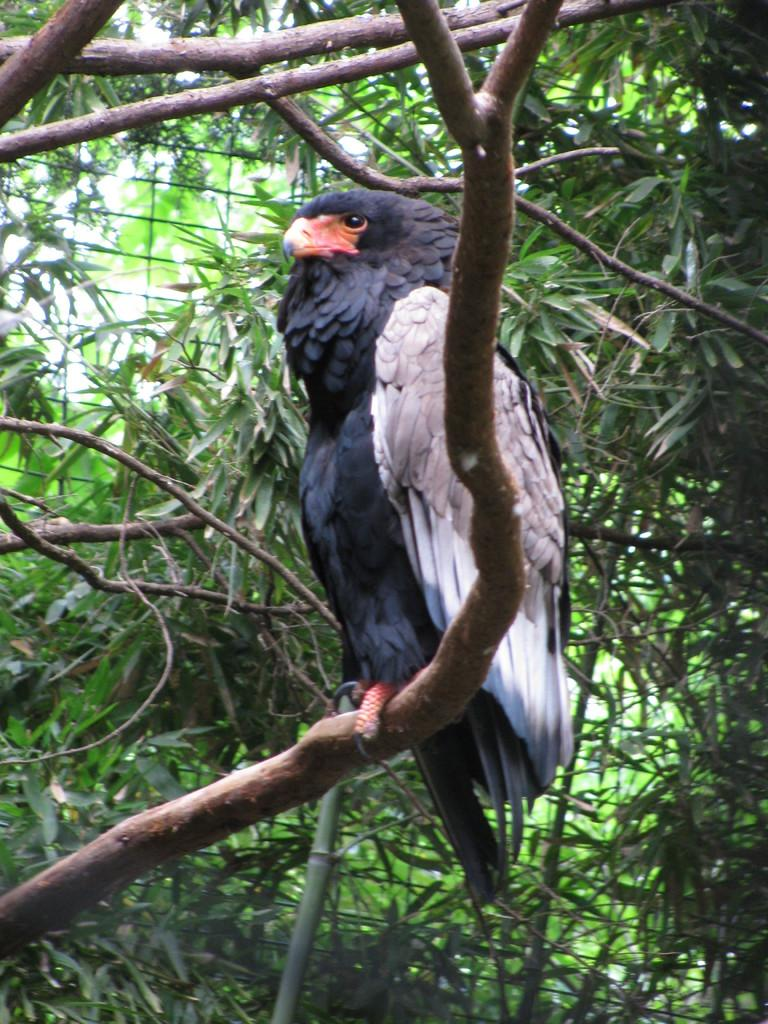What type of animal can be seen in the image? There is a bird in the image. Where is the bird located? The bird is on a branch of a tree. What can be seen in the background of the image? There are trees in the background of the image. What type of comb does the bird use to groom its feathers in the image? There is no comb present in the image, and birds do not use combs to groom their feathers. 